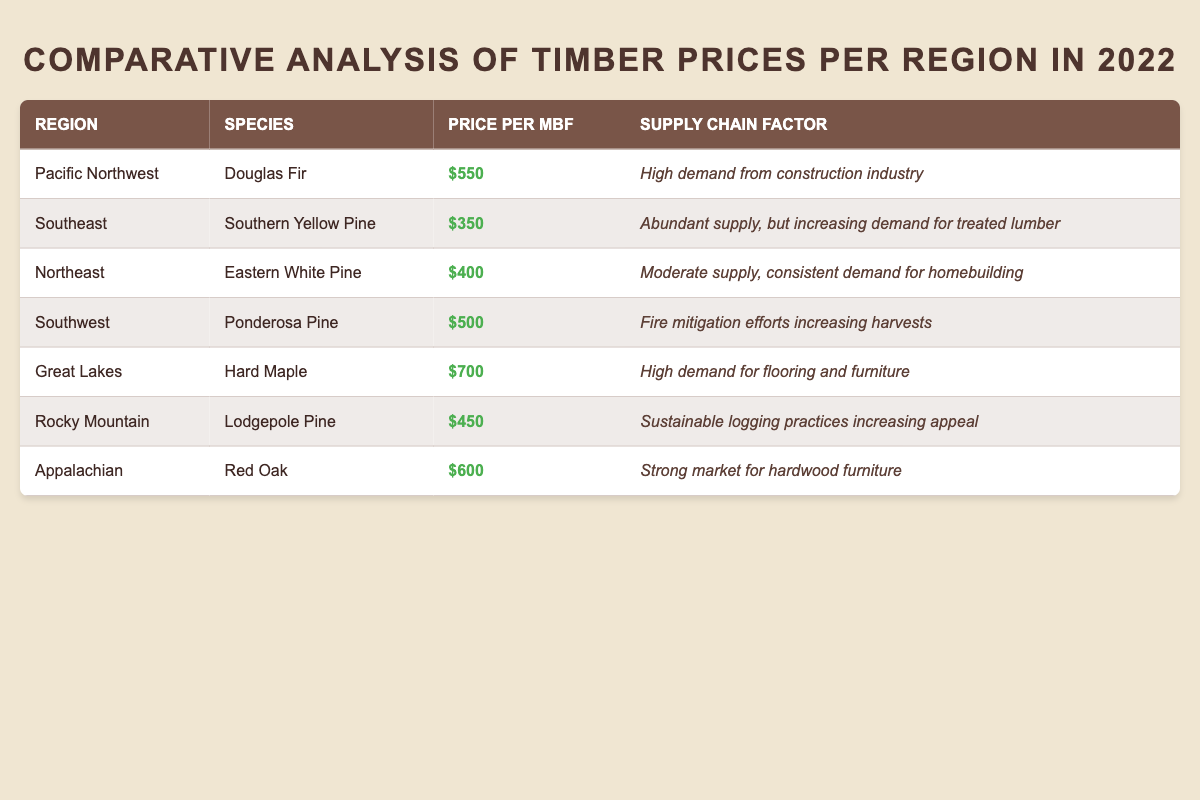What is the highest price per MBF for timber in 2022? Looking at the table, the maximum price per MBF is found in the Great Lakes region for Hard Maple, which is $700.
Answer: $700 Which timber species has the lowest price per MBF in 2022? The species with the lowest price per MBF is Southern Yellow Pine from the Southeast region, priced at $350.
Answer: Southern Yellow Pine What is the average price per MBF across all regions? To find the average, sum the prices: 550 + 350 + 400 + 500 + 700 + 450 + 600 = 3500. There are 7 regions, so the average is 3500/7 = 500.
Answer: $500 What region has the highest price for Douglas Fir per MBF? The only region listed for Douglas Fir is the Pacific Northwest, with a price of $550, making it the highest by default.
Answer: Pacific Northwest Is the supply chain factor for the Great Lakes region more favorable for furniture than in the Northeast? The supply chain factor for the Great Lakes mentions high demand for flooring and furniture, while the Northeast indicates consistent demand for homebuilding. Thus, the Great Lakes has a more favorable factor for furniture.
Answer: Yes How many regions have timber prices above $500 per MBF? The regions with prices above $500 are the Great Lakes ($700) and Appalachian ($600), which totals 2 regions.
Answer: 2 What is the price difference between the highest and lowest timber prices in 2022? The highest price is $700 (Great Lakes) and the lowest is $350 (Southeast). The difference is 700 - 350 = $350.
Answer: $350 Does the Southwest region have a higher price than the Rocky Mountain region? The Southwest price is $500, while Rocky Mountain is $450. Since $500 is greater than $450, Southwest does have a higher price.
Answer: Yes Which supply chain factor indicates an increase in timber harvests? The supply chain factor for Southwest indicates "Fire mitigation efforts increasing harvests," which implies an increase in timber harvests there.
Answer: Southwest What is the price per MBF for Eastern White Pine? The price per MBF for Eastern White Pine in the Northeast is stated as $400.
Answer: $400 